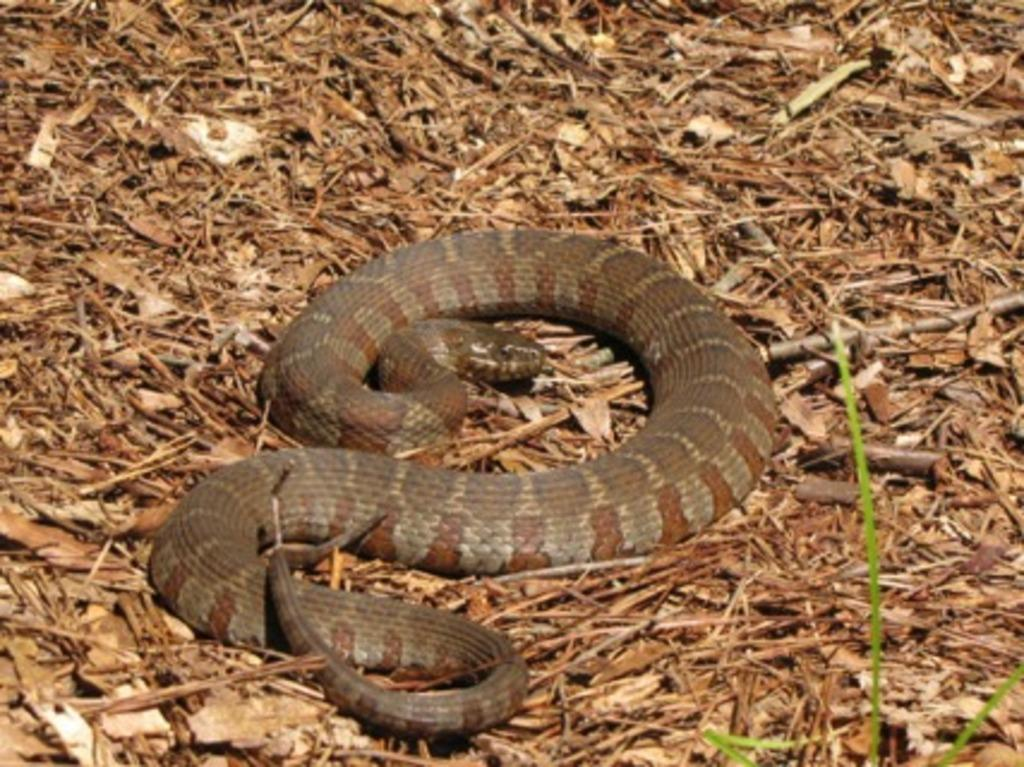What type of animal is present in the image? There is a snake in the image. What can be seen on the ground in the image? There are dried leaves on the ground in the image. What type of machine can be seen in the image? There is no machine present in the image. Is there a shop visible in the image? There is no shop present in the image. What type of beverage is being served in the image? There is no beverage, such as soda, present in the image. 